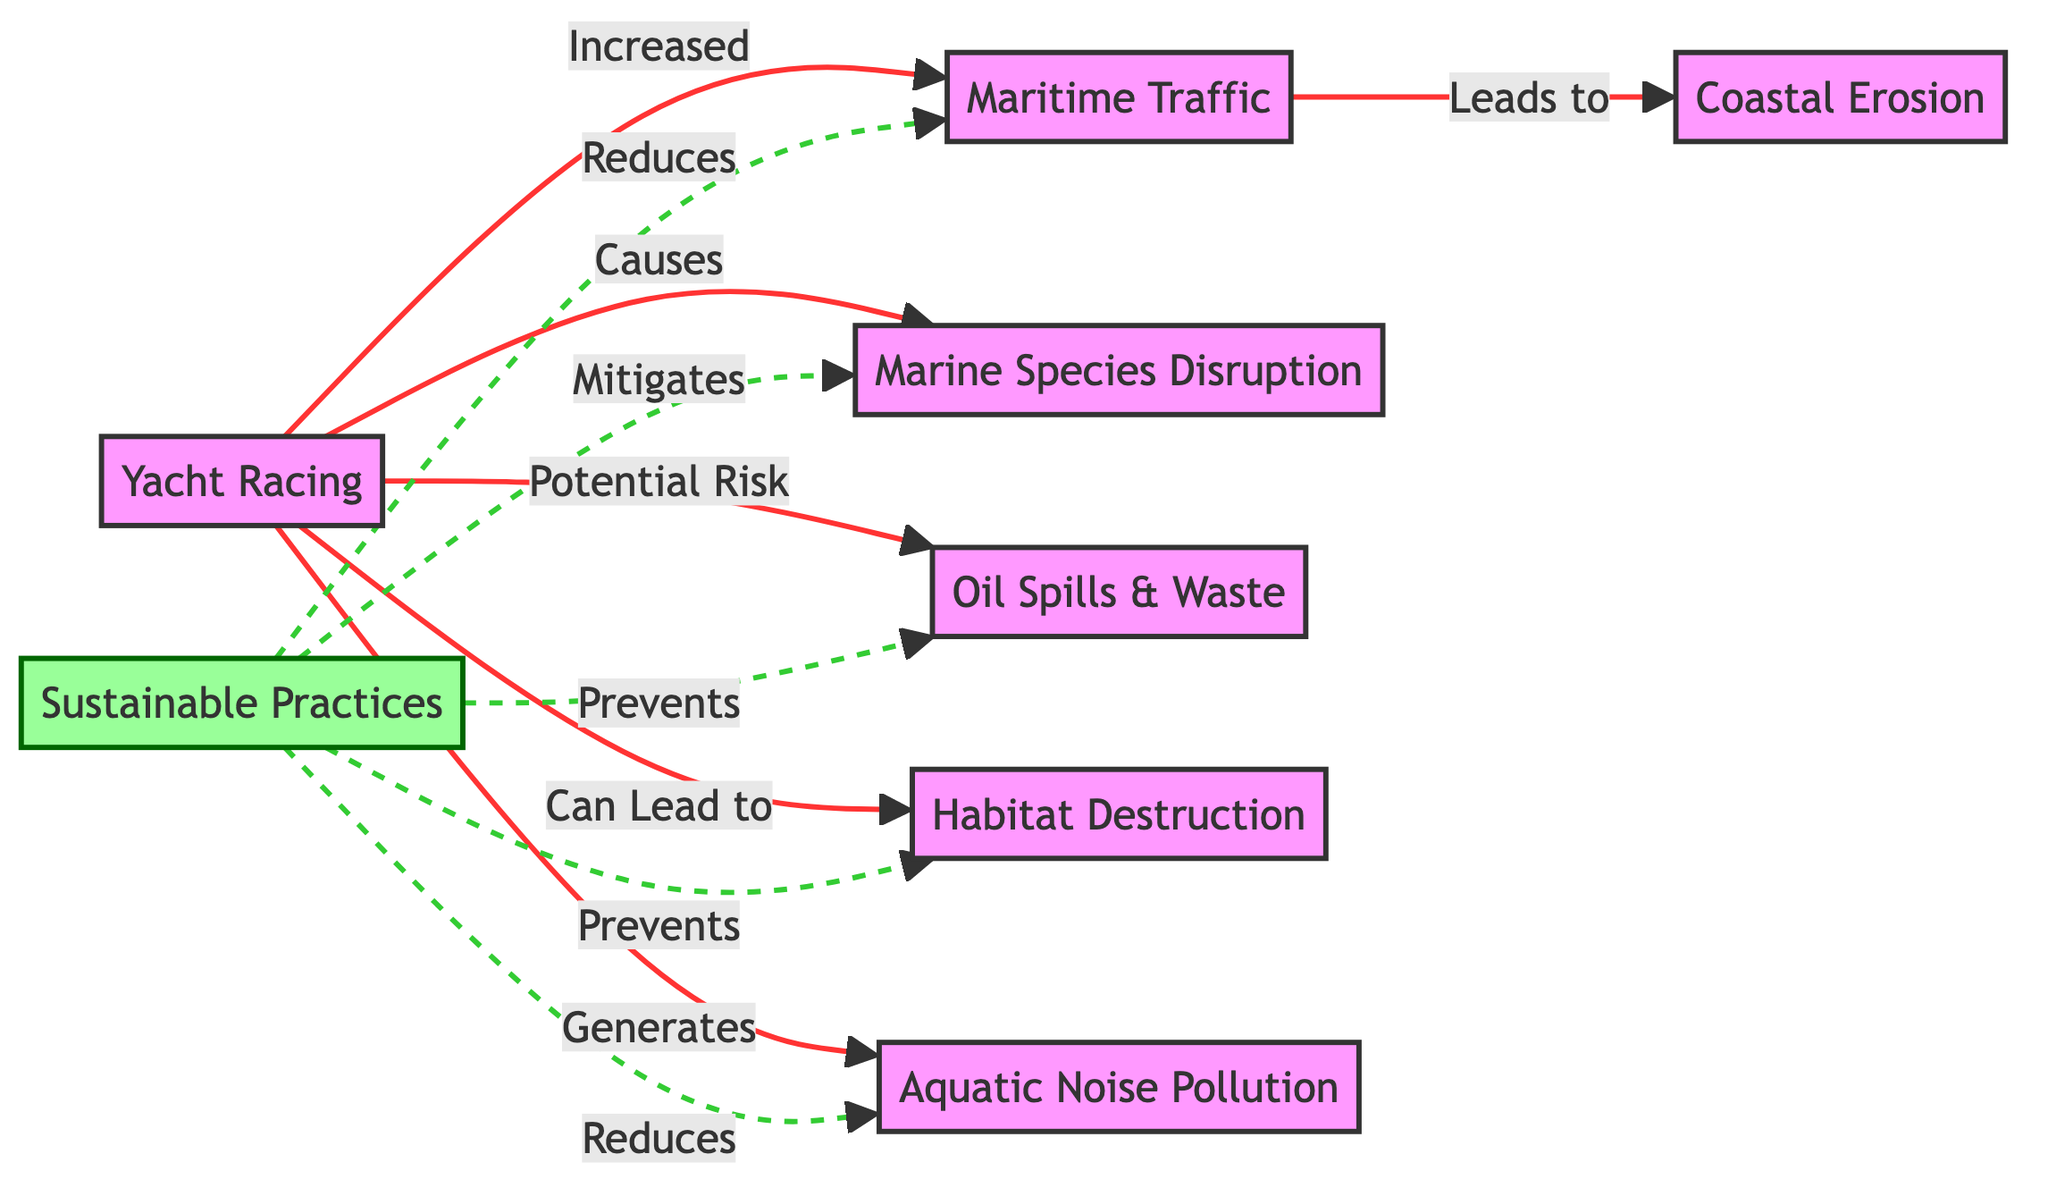What nodes are directly connected to yacht racing? Reviewing the diagram, yacht racing has direct connections to maritime traffic, marine species disruption, oil spills, habitat destruction, and aquatic noise. These connections show the various impacts yacht racing has on the environment.
Answer: maritime traffic, marine species disruption, oil spills, habitat destruction, aquatic noise How many impacts does yacht racing have on marine ecosystems? The diagram shows that yacht racing connects to five distinct impacts: maritime traffic, marine species disruption, oil spills, habitat destruction, and aquatic noise. Counting these gives the total.
Answer: 5 What type of relationship does sustainable practices have with maritime traffic? In the diagram, the relationship shown is that sustainable practices reduce maritime traffic. This indicates a positive effect of sustainable practices on mitigating one of yacht racing's impacts.
Answer: Reduces Which impact is associated with both maritime traffic and yacht racing? Maritime traffic leads to coastal erosion, which is linked back to yacht racing. The relationship suggests that both yacht racing and maritime traffic contribute to this environmental issue.
Answer: Coastal erosion What is the role of sustainable practices concerning habitat destruction? According to the diagram, sustainable practices prevent habitat destruction, showing its significant role in protecting marine ecosystems from the adverse effects caused by yacht racing.
Answer: Prevents How does aquatic noise relate to yacht racing? Aquatic noise is generated as a result of yacht racing, indicating that yacht racing contributes to noise pollution in marine environments. The flow of the diagram connects these concepts directly.
Answer: Generates Which two environmental issues can sustainable practices mitigate? The diagram indicates sustainable practices can mitigate both marine species disruption and habitat destruction, demonstrating the benefits of implementing sustainable techniques in yacht racing.
Answer: Marine species disruption, habitat destruction What is the visual style of the connections linking sustainable practices to impacts? The diagram shows those connections represented with dashed lines, differentiating them from other direct impacts of yacht racing, which are solid lines. This stylistic choice emphasizes the preventative nature of sustainable practices.
Answer: Dashed lines 